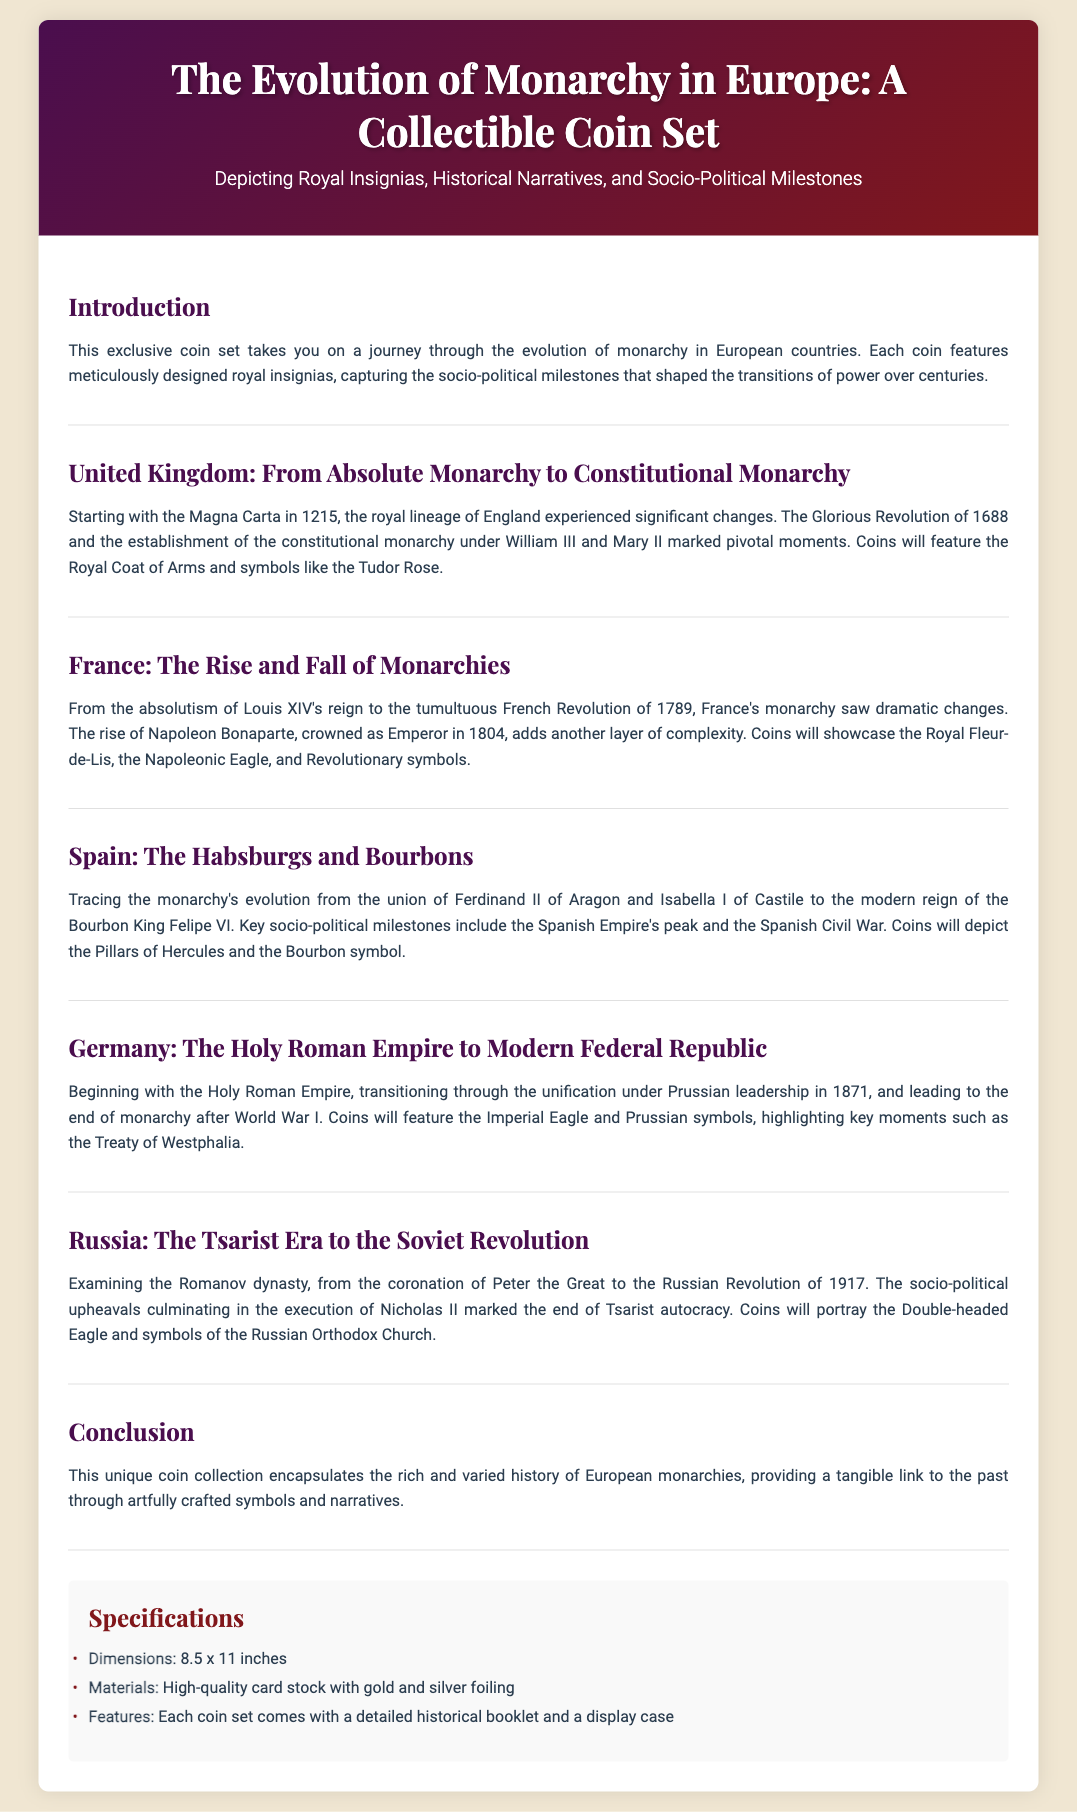What is the main theme of the collectible coin set? The document states that the main theme is the evolution of monarchy in European countries.
Answer: Evolution of monarchy in Europe Which ancient document marked a significant change in the UK monarchy? The document mentions the Magna Carta as a key milestone in the UK monarchy.
Answer: Magna Carta What symbol is featured on coins representing the UK? The UK section highlights the Royal Coat of Arms as a featured symbol.
Answer: Royal Coat of Arms In which year did the French Revolution occur? The document specifies that the French Revolution occurred in 1789.
Answer: 1789 What significant event marked the end of Tsarist autocracy in Russia? According to the document, the Russian Revolution of 1917 marked this end.
Answer: Russian Revolution of 1917 What is the size of the coin set packaging? The specifications section lists the dimensions of the coin set packaging as 8.5 x 11 inches.
Answer: 8.5 x 11 inches What type of materials are used for the coin set packaging? The packaging specifies that it is made of high-quality card stock with gold and silver foiling.
Answer: High-quality card stock with gold and silver foiling Which major socio-political milestone is associated with Germany in the document? The unification under Prussian leadership in 1871 is a key milestone mentioned for Germany.
Answer: Unification under Prussian leadership in 1871 What is included with each coin set as stated in the specifications? The specifications highlight that a detailed historical booklet comes with each coin set.
Answer: Detailed historical booklet 